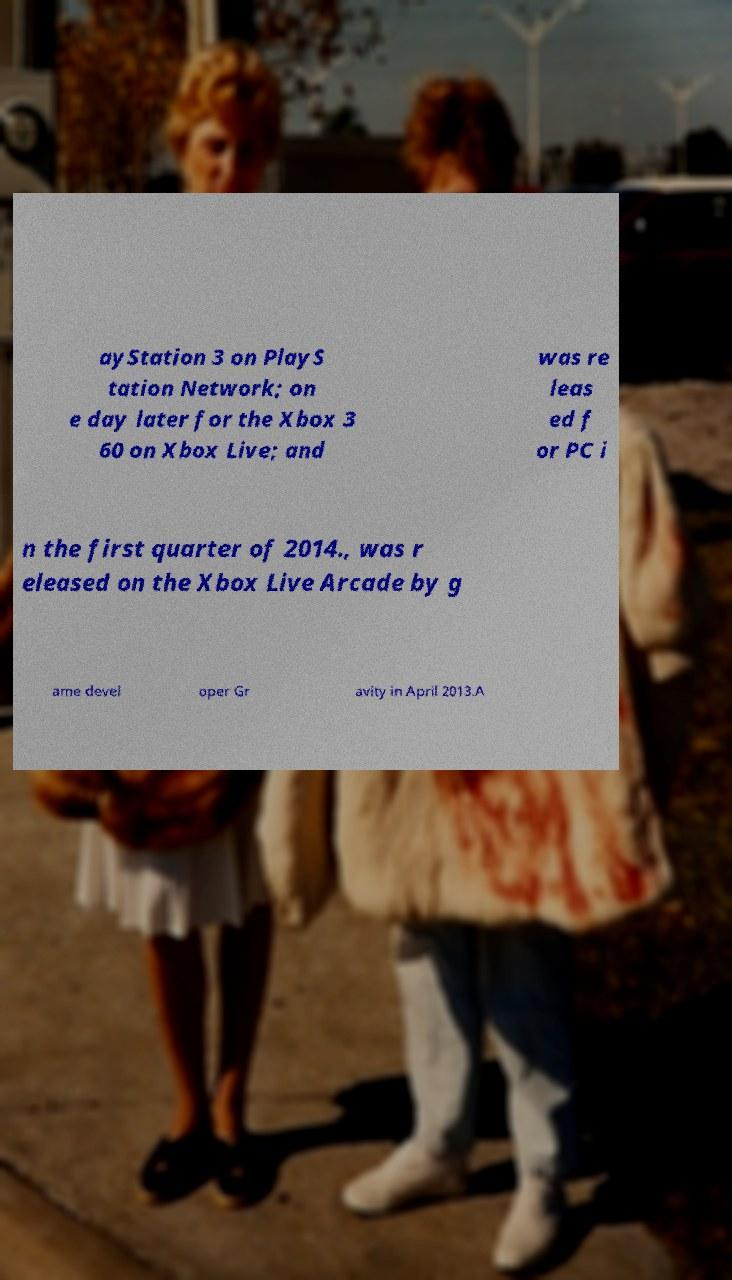Could you extract and type out the text from this image? ayStation 3 on PlayS tation Network; on e day later for the Xbox 3 60 on Xbox Live; and was re leas ed f or PC i n the first quarter of 2014., was r eleased on the Xbox Live Arcade by g ame devel oper Gr avity in April 2013.A 